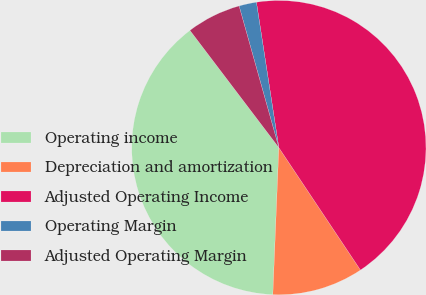<chart> <loc_0><loc_0><loc_500><loc_500><pie_chart><fcel>Operating income<fcel>Depreciation and amortization<fcel>Adjusted Operating Income<fcel>Operating Margin<fcel>Adjusted Operating Margin<nl><fcel>39.03%<fcel>10.01%<fcel>43.08%<fcel>1.92%<fcel>5.97%<nl></chart> 